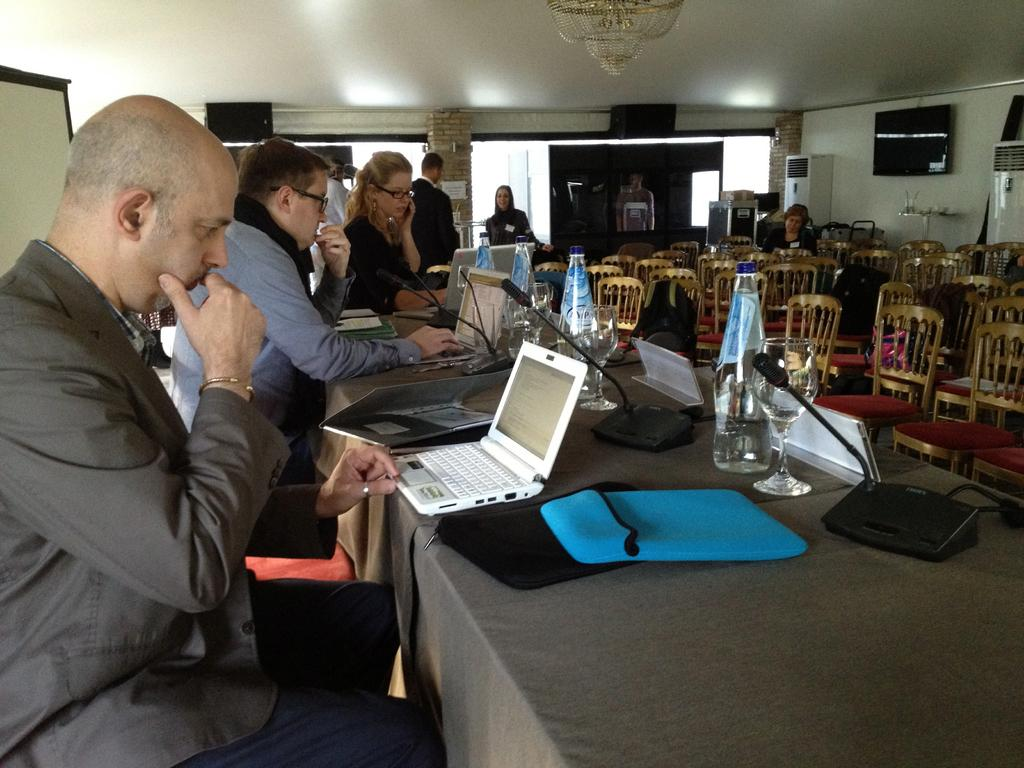What can be seen in the image involving multiple individuals? There is a group of people in the image. What electronic device is present on a table in the image? There is a laptop on a table in the image. What other object is on the table with the laptop? There is a bottle on the table in the image. How many chairs are visible in the hall in the image? There are many chairs in the hall in the image. How does the group of people in the image show their attention to the laptop? The image does not show the group of people interacting with the laptop, so it cannot be determined how they show their attention to it. 